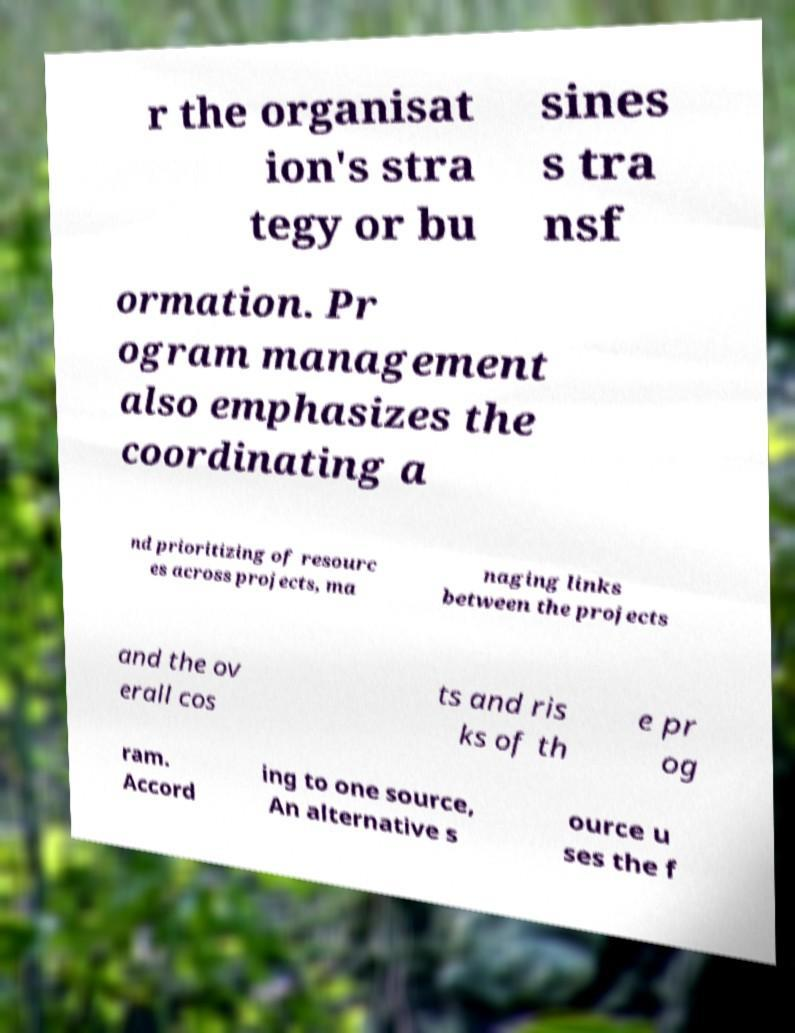There's text embedded in this image that I need extracted. Can you transcribe it verbatim? r the organisat ion's stra tegy or bu sines s tra nsf ormation. Pr ogram management also emphasizes the coordinating a nd prioritizing of resourc es across projects, ma naging links between the projects and the ov erall cos ts and ris ks of th e pr og ram. Accord ing to one source, An alternative s ource u ses the f 